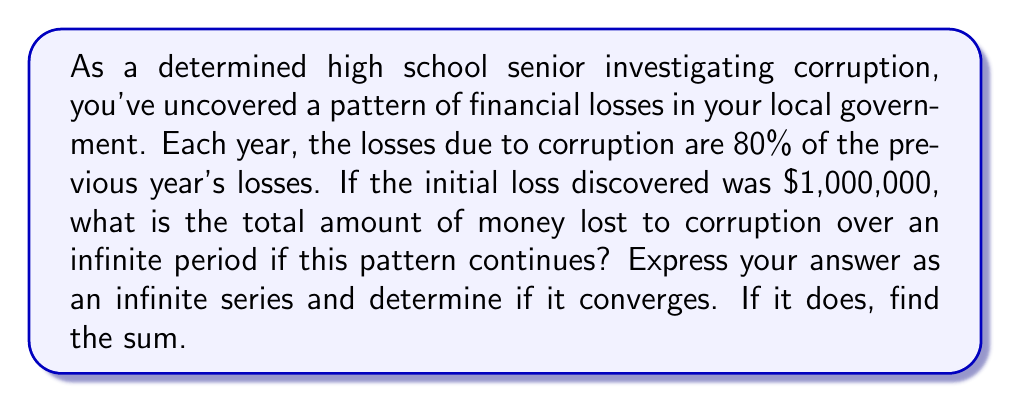Help me with this question. Let's approach this step-by-step:

1) First, let's define our series. Let $a_n$ be the loss in the nth year.
   $a_1 = 1,000,000$ (initial loss)
   $a_2 = 0.8 \times 1,000,000 = 800,000$
   $a_3 = 0.8 \times 800,000 = 640,000$
   And so on...

2) We can see that this forms a geometric series with:
   First term $a = 1,000,000$
   Common ratio $r = 0.8$

3) The infinite series can be written as:
   $S_{\infty} = 1,000,000 + 800,000 + 640,000 + ...$
   $S_{\infty} = 1,000,000(1 + 0.8 + 0.8^2 + ...)$

4) For a geometric series to converge, we need $|r| < 1$. Here, $r = 0.8$, which satisfies this condition.

5) For a convergent geometric series, the sum is given by the formula:
   $S_{\infty} = \frac{a}{1-r}$ where $a$ is the first term and $r$ is the common ratio.

6) Substituting our values:
   $S_{\infty} = \frac{1,000,000}{1-0.8} = \frac{1,000,000}{0.2} = 5,000,000$

Therefore, the series converges to $5,000,000.
Answer: The infinite series converges to $5,000,000. 